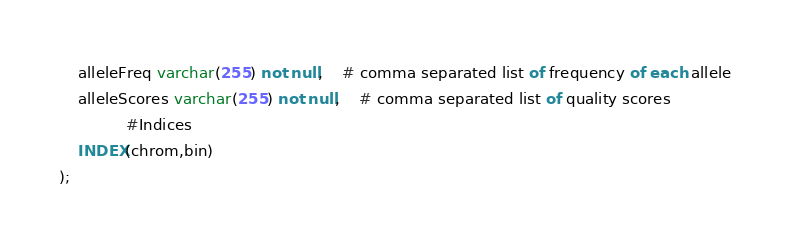<code> <loc_0><loc_0><loc_500><loc_500><_SQL_>    alleleFreq varchar(255) not null,	# comma separated list of frequency of each allele
    alleleScores varchar(255) not null,	# comma separated list of quality scores
              #Indices
    INDEX(chrom,bin)
);
</code> 